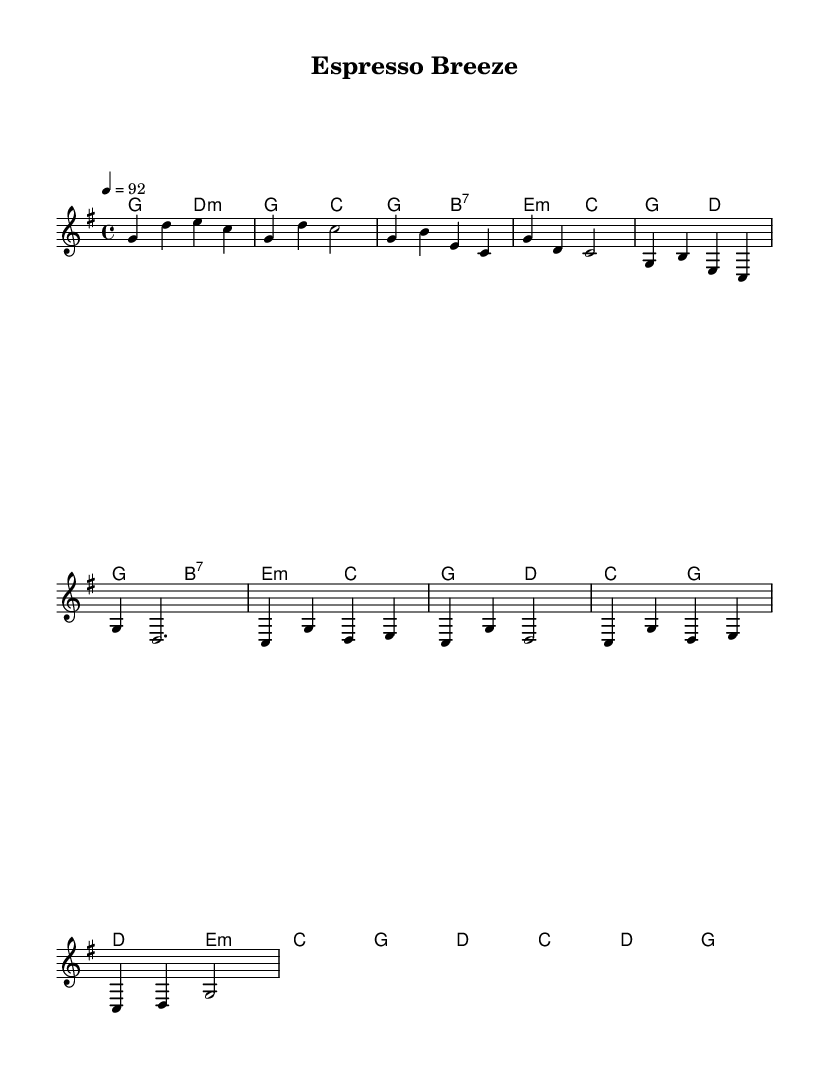What is the key signature of this music? The key signature is G major, which has one sharp (F#). This can be determined from the key signature indicated at the beginning of the sheet music.
Answer: G major What is the time signature of this music? The time signature is 4/4, which means there are four beats in each measure and the quarter note gets one beat. This is indicated at the start of the piece.
Answer: 4/4 What is the tempo marking of this music? The tempo marking indicates a speed of 92 beats per minute (BPM), which can be found in the tempo indication provided in the score.
Answer: 92 How many measures are there in the melody section? Counting the measures within the melody part from the provided excerpt, there are a total of 8 measures. This count includes all the measures from the intro, verse, and chorus sections.
Answer: 8 What type of chord progression is primarily used in the verse? The verse primarily uses a progression involving major and minor chords common in reggae fusion. Specifically, it alternates between G major, B7, E minor, and C major, which reflects a typical reggae feel.
Answer: G, B7, E minor, C Is the rhythm in the chorus consistent throughout? In the chorus, the rhythmic pattern is consistent, primarily moving in quarter notes, which fits the reggae style of maintaining a steady beat while allowing for syncopation.
Answer: Yes What style of music is this piece classified as? This piece is classified as reggae fusion, characterized by its blending of traditional reggae elements with other genres, and is conducive to a coffee shop ambiance with an island vibe.
Answer: Reggae fusion 